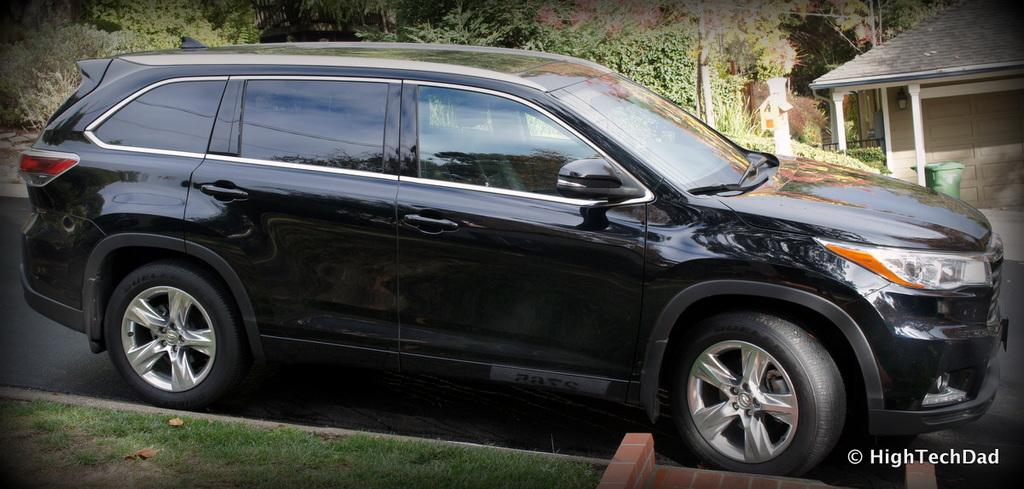What is the main subject in the center of the image? There is a black color car in the center of the image. What can be seen in the top right side of the image? There is a hut in the top right side of the image. What type of natural elements are visible in the background of the image? There are trees in the background area of the image. Can you see an actor wearing a veil in the image? There is no actor or veil present in the image. 